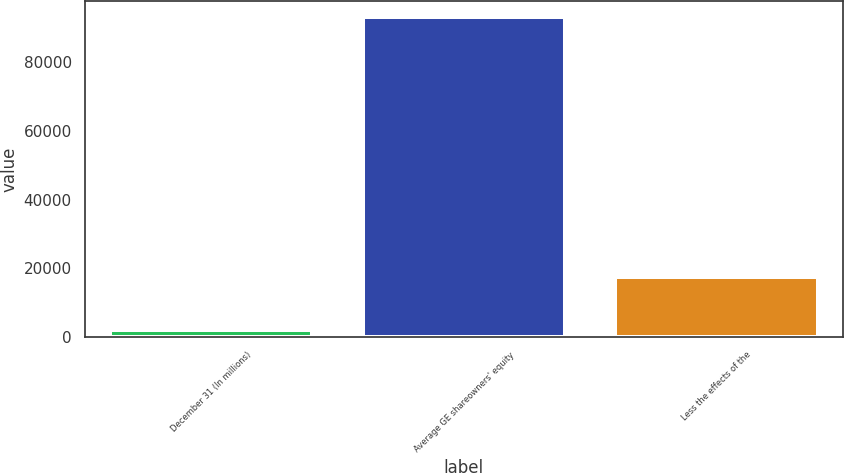Convert chart to OTSL. <chart><loc_0><loc_0><loc_500><loc_500><bar_chart><fcel>December 31 (In millions)<fcel>Average GE shareowners' equity<fcel>Less the effects of the<nl><fcel>2009<fcel>93103<fcel>17432<nl></chart> 